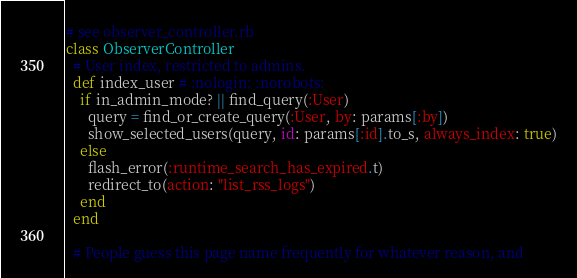<code> <loc_0><loc_0><loc_500><loc_500><_Ruby_># see observer_controller.rb
class ObserverController
  # User index, restricted to admins.
  def index_user # :nologin: :norobots:
    if in_admin_mode? || find_query(:User)
      query = find_or_create_query(:User, by: params[:by])
      show_selected_users(query, id: params[:id].to_s, always_index: true)
    else
      flash_error(:runtime_search_has_expired.t)
      redirect_to(action: "list_rss_logs")
    end
  end

  # People guess this page name frequently for whatever reason, and</code> 